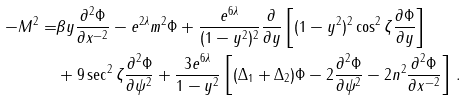Convert formula to latex. <formula><loc_0><loc_0><loc_500><loc_500>- M ^ { 2 } = & \beta y \frac { \partial ^ { 2 } \Phi } { \partial x ^ { - 2 } } - e ^ { 2 \lambda } m ^ { 2 } \Phi + \frac { e ^ { 6 \lambda } } { ( 1 - y ^ { 2 } ) ^ { 2 } } \frac { \partial } { \partial y } \left [ ( 1 - y ^ { 2 } ) ^ { 2 } \cos ^ { 2 } \zeta \frac { \partial \Phi } { \partial y } \right ] \\ & + 9 \sec ^ { 2 } \zeta \frac { \partial ^ { 2 } \Phi } { \partial \psi ^ { 2 } } + \frac { 3 e ^ { 6 \lambda } } { 1 - y ^ { 2 } } \left [ ( \Delta _ { 1 } + \Delta _ { 2 } ) \Phi - 2 \frac { \partial ^ { 2 } \Phi } { \partial \psi ^ { 2 } } - 2 n ^ { 2 } \frac { \partial ^ { 2 } \Phi } { \partial x ^ { - 2 } } \right ] \, .</formula> 